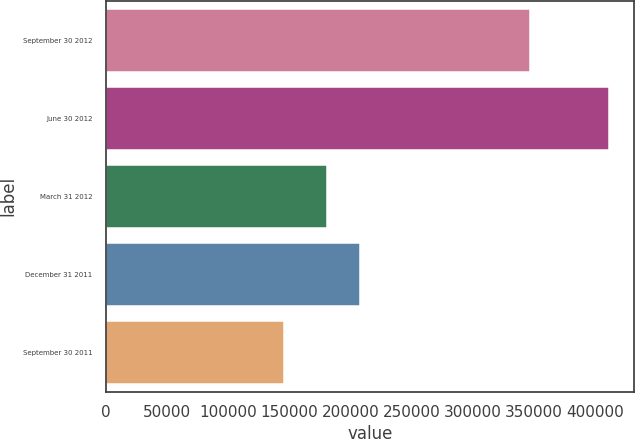<chart> <loc_0><loc_0><loc_500><loc_500><bar_chart><fcel>September 30 2012<fcel>June 30 2012<fcel>March 31 2012<fcel>December 31 2011<fcel>September 30 2011<nl><fcel>346654<fcel>411238<fcel>180875<fcel>207441<fcel>145574<nl></chart> 